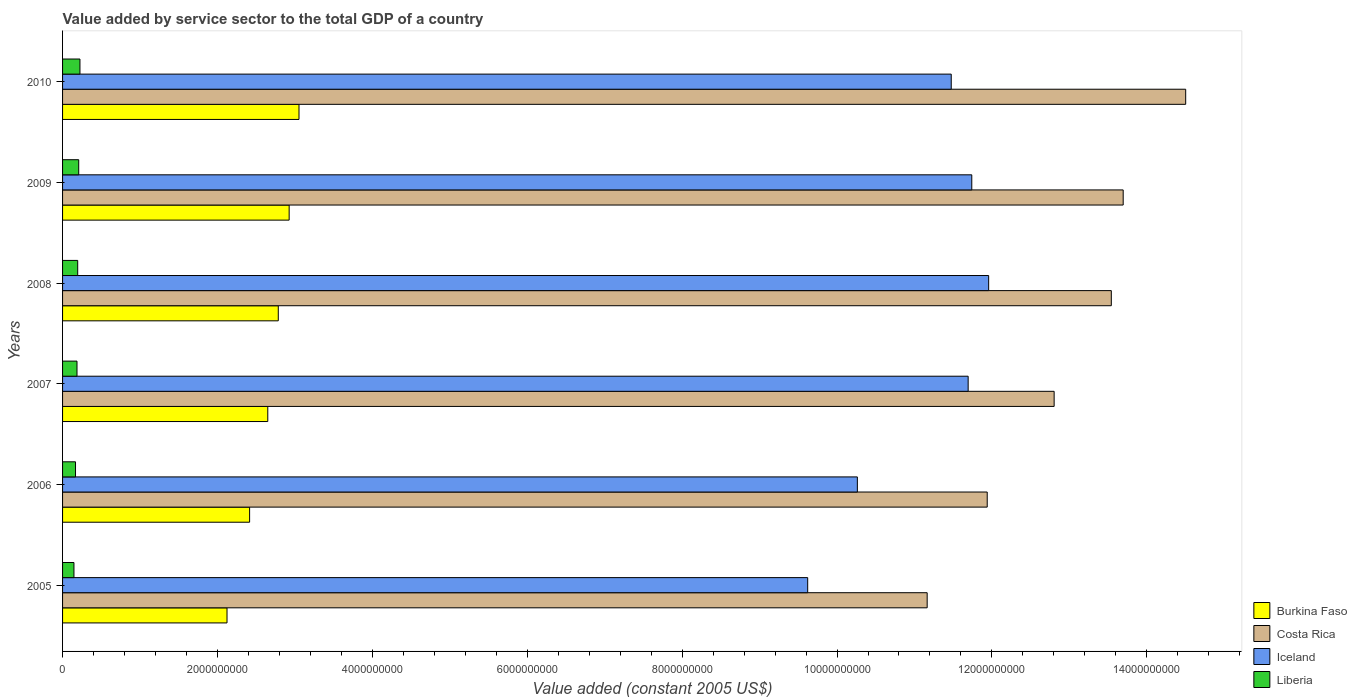How many groups of bars are there?
Provide a succinct answer. 6. Are the number of bars per tick equal to the number of legend labels?
Keep it short and to the point. Yes. How many bars are there on the 6th tick from the bottom?
Ensure brevity in your answer.  4. In how many cases, is the number of bars for a given year not equal to the number of legend labels?
Offer a very short reply. 0. What is the value added by service sector in Iceland in 2010?
Offer a very short reply. 1.15e+1. Across all years, what is the maximum value added by service sector in Burkina Faso?
Provide a short and direct response. 3.05e+09. Across all years, what is the minimum value added by service sector in Iceland?
Your answer should be very brief. 9.62e+09. In which year was the value added by service sector in Burkina Faso maximum?
Keep it short and to the point. 2010. What is the total value added by service sector in Burkina Faso in the graph?
Your answer should be compact. 1.60e+1. What is the difference between the value added by service sector in Liberia in 2005 and that in 2007?
Provide a succinct answer. -3.95e+07. What is the difference between the value added by service sector in Iceland in 2006 and the value added by service sector in Costa Rica in 2008?
Your response must be concise. -3.28e+09. What is the average value added by service sector in Liberia per year?
Give a very brief answer. 1.88e+08. In the year 2006, what is the difference between the value added by service sector in Iceland and value added by service sector in Liberia?
Your response must be concise. 1.01e+1. What is the ratio of the value added by service sector in Iceland in 2009 to that in 2010?
Offer a terse response. 1.02. Is the value added by service sector in Costa Rica in 2009 less than that in 2010?
Your response must be concise. Yes. What is the difference between the highest and the second highest value added by service sector in Burkina Faso?
Your answer should be compact. 1.27e+08. What is the difference between the highest and the lowest value added by service sector in Liberia?
Keep it short and to the point. 7.76e+07. Is it the case that in every year, the sum of the value added by service sector in Liberia and value added by service sector in Costa Rica is greater than the sum of value added by service sector in Iceland and value added by service sector in Burkina Faso?
Your response must be concise. Yes. What does the 4th bar from the top in 2009 represents?
Offer a very short reply. Burkina Faso. What does the 1st bar from the bottom in 2008 represents?
Your response must be concise. Burkina Faso. Are all the bars in the graph horizontal?
Provide a short and direct response. Yes. What is the difference between two consecutive major ticks on the X-axis?
Your response must be concise. 2.00e+09. Are the values on the major ticks of X-axis written in scientific E-notation?
Keep it short and to the point. No. Where does the legend appear in the graph?
Ensure brevity in your answer.  Bottom right. How many legend labels are there?
Offer a very short reply. 4. What is the title of the graph?
Provide a short and direct response. Value added by service sector to the total GDP of a country. What is the label or title of the X-axis?
Make the answer very short. Value added (constant 2005 US$). What is the Value added (constant 2005 US$) in Burkina Faso in 2005?
Provide a succinct answer. 2.12e+09. What is the Value added (constant 2005 US$) in Costa Rica in 2005?
Your answer should be compact. 1.12e+1. What is the Value added (constant 2005 US$) in Iceland in 2005?
Your answer should be compact. 9.62e+09. What is the Value added (constant 2005 US$) in Liberia in 2005?
Your answer should be very brief. 1.47e+08. What is the Value added (constant 2005 US$) of Burkina Faso in 2006?
Provide a short and direct response. 2.42e+09. What is the Value added (constant 2005 US$) in Costa Rica in 2006?
Your response must be concise. 1.19e+1. What is the Value added (constant 2005 US$) of Iceland in 2006?
Provide a short and direct response. 1.03e+1. What is the Value added (constant 2005 US$) of Liberia in 2006?
Make the answer very short. 1.67e+08. What is the Value added (constant 2005 US$) of Burkina Faso in 2007?
Provide a short and direct response. 2.65e+09. What is the Value added (constant 2005 US$) in Costa Rica in 2007?
Your response must be concise. 1.28e+1. What is the Value added (constant 2005 US$) of Iceland in 2007?
Your answer should be compact. 1.17e+1. What is the Value added (constant 2005 US$) in Liberia in 2007?
Provide a short and direct response. 1.86e+08. What is the Value added (constant 2005 US$) of Burkina Faso in 2008?
Give a very brief answer. 2.79e+09. What is the Value added (constant 2005 US$) in Costa Rica in 2008?
Ensure brevity in your answer.  1.35e+1. What is the Value added (constant 2005 US$) of Iceland in 2008?
Your answer should be compact. 1.20e+1. What is the Value added (constant 2005 US$) in Liberia in 2008?
Offer a terse response. 1.95e+08. What is the Value added (constant 2005 US$) in Burkina Faso in 2009?
Provide a succinct answer. 2.93e+09. What is the Value added (constant 2005 US$) in Costa Rica in 2009?
Provide a succinct answer. 1.37e+1. What is the Value added (constant 2005 US$) of Iceland in 2009?
Your response must be concise. 1.17e+1. What is the Value added (constant 2005 US$) of Liberia in 2009?
Give a very brief answer. 2.09e+08. What is the Value added (constant 2005 US$) in Burkina Faso in 2010?
Your answer should be compact. 3.05e+09. What is the Value added (constant 2005 US$) of Costa Rica in 2010?
Provide a succinct answer. 1.45e+1. What is the Value added (constant 2005 US$) in Iceland in 2010?
Keep it short and to the point. 1.15e+1. What is the Value added (constant 2005 US$) in Liberia in 2010?
Offer a very short reply. 2.25e+08. Across all years, what is the maximum Value added (constant 2005 US$) of Burkina Faso?
Ensure brevity in your answer.  3.05e+09. Across all years, what is the maximum Value added (constant 2005 US$) of Costa Rica?
Ensure brevity in your answer.  1.45e+1. Across all years, what is the maximum Value added (constant 2005 US$) in Iceland?
Give a very brief answer. 1.20e+1. Across all years, what is the maximum Value added (constant 2005 US$) of Liberia?
Your answer should be compact. 2.25e+08. Across all years, what is the minimum Value added (constant 2005 US$) of Burkina Faso?
Give a very brief answer. 2.12e+09. Across all years, what is the minimum Value added (constant 2005 US$) of Costa Rica?
Provide a short and direct response. 1.12e+1. Across all years, what is the minimum Value added (constant 2005 US$) of Iceland?
Your answer should be compact. 9.62e+09. Across all years, what is the minimum Value added (constant 2005 US$) in Liberia?
Give a very brief answer. 1.47e+08. What is the total Value added (constant 2005 US$) in Burkina Faso in the graph?
Provide a short and direct response. 1.60e+1. What is the total Value added (constant 2005 US$) of Costa Rica in the graph?
Offer a very short reply. 7.76e+1. What is the total Value added (constant 2005 US$) of Iceland in the graph?
Your answer should be compact. 6.68e+1. What is the total Value added (constant 2005 US$) of Liberia in the graph?
Keep it short and to the point. 1.13e+09. What is the difference between the Value added (constant 2005 US$) of Burkina Faso in 2005 and that in 2006?
Provide a short and direct response. -2.92e+08. What is the difference between the Value added (constant 2005 US$) in Costa Rica in 2005 and that in 2006?
Your answer should be compact. -7.75e+08. What is the difference between the Value added (constant 2005 US$) in Iceland in 2005 and that in 2006?
Give a very brief answer. -6.41e+08. What is the difference between the Value added (constant 2005 US$) of Liberia in 2005 and that in 2006?
Make the answer very short. -2.02e+07. What is the difference between the Value added (constant 2005 US$) in Burkina Faso in 2005 and that in 2007?
Ensure brevity in your answer.  -5.26e+08. What is the difference between the Value added (constant 2005 US$) in Costa Rica in 2005 and that in 2007?
Your response must be concise. -1.64e+09. What is the difference between the Value added (constant 2005 US$) of Iceland in 2005 and that in 2007?
Offer a very short reply. -2.07e+09. What is the difference between the Value added (constant 2005 US$) in Liberia in 2005 and that in 2007?
Keep it short and to the point. -3.95e+07. What is the difference between the Value added (constant 2005 US$) in Burkina Faso in 2005 and that in 2008?
Offer a terse response. -6.62e+08. What is the difference between the Value added (constant 2005 US$) of Costa Rica in 2005 and that in 2008?
Your answer should be compact. -2.38e+09. What is the difference between the Value added (constant 2005 US$) of Iceland in 2005 and that in 2008?
Your response must be concise. -2.34e+09. What is the difference between the Value added (constant 2005 US$) of Liberia in 2005 and that in 2008?
Give a very brief answer. -4.85e+07. What is the difference between the Value added (constant 2005 US$) of Burkina Faso in 2005 and that in 2009?
Your answer should be very brief. -8.02e+08. What is the difference between the Value added (constant 2005 US$) of Costa Rica in 2005 and that in 2009?
Keep it short and to the point. -2.53e+09. What is the difference between the Value added (constant 2005 US$) in Iceland in 2005 and that in 2009?
Keep it short and to the point. -2.12e+09. What is the difference between the Value added (constant 2005 US$) in Liberia in 2005 and that in 2009?
Your answer should be very brief. -6.16e+07. What is the difference between the Value added (constant 2005 US$) in Burkina Faso in 2005 and that in 2010?
Give a very brief answer. -9.29e+08. What is the difference between the Value added (constant 2005 US$) in Costa Rica in 2005 and that in 2010?
Give a very brief answer. -3.34e+09. What is the difference between the Value added (constant 2005 US$) of Iceland in 2005 and that in 2010?
Offer a very short reply. -1.85e+09. What is the difference between the Value added (constant 2005 US$) of Liberia in 2005 and that in 2010?
Offer a very short reply. -7.76e+07. What is the difference between the Value added (constant 2005 US$) of Burkina Faso in 2006 and that in 2007?
Offer a terse response. -2.35e+08. What is the difference between the Value added (constant 2005 US$) in Costa Rica in 2006 and that in 2007?
Offer a very short reply. -8.64e+08. What is the difference between the Value added (constant 2005 US$) in Iceland in 2006 and that in 2007?
Make the answer very short. -1.43e+09. What is the difference between the Value added (constant 2005 US$) of Liberia in 2006 and that in 2007?
Provide a succinct answer. -1.92e+07. What is the difference between the Value added (constant 2005 US$) in Burkina Faso in 2006 and that in 2008?
Provide a succinct answer. -3.70e+08. What is the difference between the Value added (constant 2005 US$) of Costa Rica in 2006 and that in 2008?
Provide a succinct answer. -1.60e+09. What is the difference between the Value added (constant 2005 US$) in Iceland in 2006 and that in 2008?
Give a very brief answer. -1.70e+09. What is the difference between the Value added (constant 2005 US$) in Liberia in 2006 and that in 2008?
Your answer should be compact. -2.83e+07. What is the difference between the Value added (constant 2005 US$) in Burkina Faso in 2006 and that in 2009?
Ensure brevity in your answer.  -5.11e+08. What is the difference between the Value added (constant 2005 US$) of Costa Rica in 2006 and that in 2009?
Your answer should be compact. -1.76e+09. What is the difference between the Value added (constant 2005 US$) in Iceland in 2006 and that in 2009?
Offer a terse response. -1.48e+09. What is the difference between the Value added (constant 2005 US$) of Liberia in 2006 and that in 2009?
Your answer should be compact. -4.13e+07. What is the difference between the Value added (constant 2005 US$) of Burkina Faso in 2006 and that in 2010?
Your answer should be compact. -6.38e+08. What is the difference between the Value added (constant 2005 US$) of Costa Rica in 2006 and that in 2010?
Make the answer very short. -2.56e+09. What is the difference between the Value added (constant 2005 US$) of Iceland in 2006 and that in 2010?
Provide a succinct answer. -1.21e+09. What is the difference between the Value added (constant 2005 US$) in Liberia in 2006 and that in 2010?
Offer a terse response. -5.74e+07. What is the difference between the Value added (constant 2005 US$) of Burkina Faso in 2007 and that in 2008?
Provide a succinct answer. -1.36e+08. What is the difference between the Value added (constant 2005 US$) in Costa Rica in 2007 and that in 2008?
Ensure brevity in your answer.  -7.38e+08. What is the difference between the Value added (constant 2005 US$) of Iceland in 2007 and that in 2008?
Provide a short and direct response. -2.65e+08. What is the difference between the Value added (constant 2005 US$) in Liberia in 2007 and that in 2008?
Give a very brief answer. -9.04e+06. What is the difference between the Value added (constant 2005 US$) in Burkina Faso in 2007 and that in 2009?
Provide a succinct answer. -2.76e+08. What is the difference between the Value added (constant 2005 US$) of Costa Rica in 2007 and that in 2009?
Your answer should be very brief. -8.92e+08. What is the difference between the Value added (constant 2005 US$) of Iceland in 2007 and that in 2009?
Give a very brief answer. -4.66e+07. What is the difference between the Value added (constant 2005 US$) of Liberia in 2007 and that in 2009?
Offer a terse response. -2.21e+07. What is the difference between the Value added (constant 2005 US$) in Burkina Faso in 2007 and that in 2010?
Provide a short and direct response. -4.03e+08. What is the difference between the Value added (constant 2005 US$) in Costa Rica in 2007 and that in 2010?
Provide a short and direct response. -1.70e+09. What is the difference between the Value added (constant 2005 US$) in Iceland in 2007 and that in 2010?
Provide a succinct answer. 2.19e+08. What is the difference between the Value added (constant 2005 US$) of Liberia in 2007 and that in 2010?
Your answer should be compact. -3.81e+07. What is the difference between the Value added (constant 2005 US$) in Burkina Faso in 2008 and that in 2009?
Give a very brief answer. -1.40e+08. What is the difference between the Value added (constant 2005 US$) in Costa Rica in 2008 and that in 2009?
Offer a terse response. -1.53e+08. What is the difference between the Value added (constant 2005 US$) of Iceland in 2008 and that in 2009?
Your response must be concise. 2.18e+08. What is the difference between the Value added (constant 2005 US$) of Liberia in 2008 and that in 2009?
Ensure brevity in your answer.  -1.31e+07. What is the difference between the Value added (constant 2005 US$) of Burkina Faso in 2008 and that in 2010?
Offer a terse response. -2.68e+08. What is the difference between the Value added (constant 2005 US$) of Costa Rica in 2008 and that in 2010?
Give a very brief answer. -9.60e+08. What is the difference between the Value added (constant 2005 US$) of Iceland in 2008 and that in 2010?
Ensure brevity in your answer.  4.83e+08. What is the difference between the Value added (constant 2005 US$) of Liberia in 2008 and that in 2010?
Your answer should be very brief. -2.91e+07. What is the difference between the Value added (constant 2005 US$) in Burkina Faso in 2009 and that in 2010?
Give a very brief answer. -1.27e+08. What is the difference between the Value added (constant 2005 US$) in Costa Rica in 2009 and that in 2010?
Your answer should be very brief. -8.07e+08. What is the difference between the Value added (constant 2005 US$) of Iceland in 2009 and that in 2010?
Give a very brief answer. 2.65e+08. What is the difference between the Value added (constant 2005 US$) in Liberia in 2009 and that in 2010?
Keep it short and to the point. -1.60e+07. What is the difference between the Value added (constant 2005 US$) in Burkina Faso in 2005 and the Value added (constant 2005 US$) in Costa Rica in 2006?
Give a very brief answer. -9.82e+09. What is the difference between the Value added (constant 2005 US$) of Burkina Faso in 2005 and the Value added (constant 2005 US$) of Iceland in 2006?
Ensure brevity in your answer.  -8.14e+09. What is the difference between the Value added (constant 2005 US$) in Burkina Faso in 2005 and the Value added (constant 2005 US$) in Liberia in 2006?
Your answer should be very brief. 1.96e+09. What is the difference between the Value added (constant 2005 US$) of Costa Rica in 2005 and the Value added (constant 2005 US$) of Iceland in 2006?
Your answer should be very brief. 9.01e+08. What is the difference between the Value added (constant 2005 US$) of Costa Rica in 2005 and the Value added (constant 2005 US$) of Liberia in 2006?
Provide a short and direct response. 1.10e+1. What is the difference between the Value added (constant 2005 US$) of Iceland in 2005 and the Value added (constant 2005 US$) of Liberia in 2006?
Offer a very short reply. 9.45e+09. What is the difference between the Value added (constant 2005 US$) in Burkina Faso in 2005 and the Value added (constant 2005 US$) in Costa Rica in 2007?
Your answer should be compact. -1.07e+1. What is the difference between the Value added (constant 2005 US$) in Burkina Faso in 2005 and the Value added (constant 2005 US$) in Iceland in 2007?
Your answer should be compact. -9.57e+09. What is the difference between the Value added (constant 2005 US$) of Burkina Faso in 2005 and the Value added (constant 2005 US$) of Liberia in 2007?
Your response must be concise. 1.94e+09. What is the difference between the Value added (constant 2005 US$) in Costa Rica in 2005 and the Value added (constant 2005 US$) in Iceland in 2007?
Offer a very short reply. -5.29e+08. What is the difference between the Value added (constant 2005 US$) of Costa Rica in 2005 and the Value added (constant 2005 US$) of Liberia in 2007?
Give a very brief answer. 1.10e+1. What is the difference between the Value added (constant 2005 US$) of Iceland in 2005 and the Value added (constant 2005 US$) of Liberia in 2007?
Keep it short and to the point. 9.43e+09. What is the difference between the Value added (constant 2005 US$) of Burkina Faso in 2005 and the Value added (constant 2005 US$) of Costa Rica in 2008?
Provide a short and direct response. -1.14e+1. What is the difference between the Value added (constant 2005 US$) of Burkina Faso in 2005 and the Value added (constant 2005 US$) of Iceland in 2008?
Offer a terse response. -9.83e+09. What is the difference between the Value added (constant 2005 US$) in Burkina Faso in 2005 and the Value added (constant 2005 US$) in Liberia in 2008?
Keep it short and to the point. 1.93e+09. What is the difference between the Value added (constant 2005 US$) of Costa Rica in 2005 and the Value added (constant 2005 US$) of Iceland in 2008?
Offer a very short reply. -7.94e+08. What is the difference between the Value added (constant 2005 US$) of Costa Rica in 2005 and the Value added (constant 2005 US$) of Liberia in 2008?
Provide a succinct answer. 1.10e+1. What is the difference between the Value added (constant 2005 US$) in Iceland in 2005 and the Value added (constant 2005 US$) in Liberia in 2008?
Give a very brief answer. 9.43e+09. What is the difference between the Value added (constant 2005 US$) of Burkina Faso in 2005 and the Value added (constant 2005 US$) of Costa Rica in 2009?
Offer a terse response. -1.16e+1. What is the difference between the Value added (constant 2005 US$) in Burkina Faso in 2005 and the Value added (constant 2005 US$) in Iceland in 2009?
Provide a succinct answer. -9.62e+09. What is the difference between the Value added (constant 2005 US$) in Burkina Faso in 2005 and the Value added (constant 2005 US$) in Liberia in 2009?
Give a very brief answer. 1.91e+09. What is the difference between the Value added (constant 2005 US$) in Costa Rica in 2005 and the Value added (constant 2005 US$) in Iceland in 2009?
Your answer should be compact. -5.76e+08. What is the difference between the Value added (constant 2005 US$) of Costa Rica in 2005 and the Value added (constant 2005 US$) of Liberia in 2009?
Provide a short and direct response. 1.10e+1. What is the difference between the Value added (constant 2005 US$) of Iceland in 2005 and the Value added (constant 2005 US$) of Liberia in 2009?
Ensure brevity in your answer.  9.41e+09. What is the difference between the Value added (constant 2005 US$) in Burkina Faso in 2005 and the Value added (constant 2005 US$) in Costa Rica in 2010?
Make the answer very short. -1.24e+1. What is the difference between the Value added (constant 2005 US$) in Burkina Faso in 2005 and the Value added (constant 2005 US$) in Iceland in 2010?
Provide a succinct answer. -9.35e+09. What is the difference between the Value added (constant 2005 US$) in Burkina Faso in 2005 and the Value added (constant 2005 US$) in Liberia in 2010?
Your response must be concise. 1.90e+09. What is the difference between the Value added (constant 2005 US$) in Costa Rica in 2005 and the Value added (constant 2005 US$) in Iceland in 2010?
Your response must be concise. -3.11e+08. What is the difference between the Value added (constant 2005 US$) of Costa Rica in 2005 and the Value added (constant 2005 US$) of Liberia in 2010?
Your answer should be compact. 1.09e+1. What is the difference between the Value added (constant 2005 US$) of Iceland in 2005 and the Value added (constant 2005 US$) of Liberia in 2010?
Make the answer very short. 9.40e+09. What is the difference between the Value added (constant 2005 US$) in Burkina Faso in 2006 and the Value added (constant 2005 US$) in Costa Rica in 2007?
Your answer should be compact. -1.04e+1. What is the difference between the Value added (constant 2005 US$) of Burkina Faso in 2006 and the Value added (constant 2005 US$) of Iceland in 2007?
Ensure brevity in your answer.  -9.28e+09. What is the difference between the Value added (constant 2005 US$) in Burkina Faso in 2006 and the Value added (constant 2005 US$) in Liberia in 2007?
Give a very brief answer. 2.23e+09. What is the difference between the Value added (constant 2005 US$) in Costa Rica in 2006 and the Value added (constant 2005 US$) in Iceland in 2007?
Make the answer very short. 2.46e+08. What is the difference between the Value added (constant 2005 US$) in Costa Rica in 2006 and the Value added (constant 2005 US$) in Liberia in 2007?
Provide a succinct answer. 1.18e+1. What is the difference between the Value added (constant 2005 US$) of Iceland in 2006 and the Value added (constant 2005 US$) of Liberia in 2007?
Offer a terse response. 1.01e+1. What is the difference between the Value added (constant 2005 US$) in Burkina Faso in 2006 and the Value added (constant 2005 US$) in Costa Rica in 2008?
Your response must be concise. -1.11e+1. What is the difference between the Value added (constant 2005 US$) in Burkina Faso in 2006 and the Value added (constant 2005 US$) in Iceland in 2008?
Ensure brevity in your answer.  -9.54e+09. What is the difference between the Value added (constant 2005 US$) in Burkina Faso in 2006 and the Value added (constant 2005 US$) in Liberia in 2008?
Offer a terse response. 2.22e+09. What is the difference between the Value added (constant 2005 US$) of Costa Rica in 2006 and the Value added (constant 2005 US$) of Iceland in 2008?
Give a very brief answer. -1.86e+07. What is the difference between the Value added (constant 2005 US$) of Costa Rica in 2006 and the Value added (constant 2005 US$) of Liberia in 2008?
Offer a terse response. 1.17e+1. What is the difference between the Value added (constant 2005 US$) in Iceland in 2006 and the Value added (constant 2005 US$) in Liberia in 2008?
Ensure brevity in your answer.  1.01e+1. What is the difference between the Value added (constant 2005 US$) in Burkina Faso in 2006 and the Value added (constant 2005 US$) in Costa Rica in 2009?
Your response must be concise. -1.13e+1. What is the difference between the Value added (constant 2005 US$) of Burkina Faso in 2006 and the Value added (constant 2005 US$) of Iceland in 2009?
Keep it short and to the point. -9.32e+09. What is the difference between the Value added (constant 2005 US$) in Burkina Faso in 2006 and the Value added (constant 2005 US$) in Liberia in 2009?
Ensure brevity in your answer.  2.21e+09. What is the difference between the Value added (constant 2005 US$) of Costa Rica in 2006 and the Value added (constant 2005 US$) of Iceland in 2009?
Your answer should be compact. 1.99e+08. What is the difference between the Value added (constant 2005 US$) of Costa Rica in 2006 and the Value added (constant 2005 US$) of Liberia in 2009?
Make the answer very short. 1.17e+1. What is the difference between the Value added (constant 2005 US$) in Iceland in 2006 and the Value added (constant 2005 US$) in Liberia in 2009?
Give a very brief answer. 1.01e+1. What is the difference between the Value added (constant 2005 US$) of Burkina Faso in 2006 and the Value added (constant 2005 US$) of Costa Rica in 2010?
Make the answer very short. -1.21e+1. What is the difference between the Value added (constant 2005 US$) of Burkina Faso in 2006 and the Value added (constant 2005 US$) of Iceland in 2010?
Make the answer very short. -9.06e+09. What is the difference between the Value added (constant 2005 US$) of Burkina Faso in 2006 and the Value added (constant 2005 US$) of Liberia in 2010?
Offer a very short reply. 2.19e+09. What is the difference between the Value added (constant 2005 US$) of Costa Rica in 2006 and the Value added (constant 2005 US$) of Iceland in 2010?
Your answer should be compact. 4.65e+08. What is the difference between the Value added (constant 2005 US$) of Costa Rica in 2006 and the Value added (constant 2005 US$) of Liberia in 2010?
Provide a succinct answer. 1.17e+1. What is the difference between the Value added (constant 2005 US$) of Iceland in 2006 and the Value added (constant 2005 US$) of Liberia in 2010?
Make the answer very short. 1.00e+1. What is the difference between the Value added (constant 2005 US$) in Burkina Faso in 2007 and the Value added (constant 2005 US$) in Costa Rica in 2008?
Give a very brief answer. -1.09e+1. What is the difference between the Value added (constant 2005 US$) in Burkina Faso in 2007 and the Value added (constant 2005 US$) in Iceland in 2008?
Give a very brief answer. -9.31e+09. What is the difference between the Value added (constant 2005 US$) of Burkina Faso in 2007 and the Value added (constant 2005 US$) of Liberia in 2008?
Make the answer very short. 2.45e+09. What is the difference between the Value added (constant 2005 US$) of Costa Rica in 2007 and the Value added (constant 2005 US$) of Iceland in 2008?
Ensure brevity in your answer.  8.45e+08. What is the difference between the Value added (constant 2005 US$) in Costa Rica in 2007 and the Value added (constant 2005 US$) in Liberia in 2008?
Ensure brevity in your answer.  1.26e+1. What is the difference between the Value added (constant 2005 US$) in Iceland in 2007 and the Value added (constant 2005 US$) in Liberia in 2008?
Keep it short and to the point. 1.15e+1. What is the difference between the Value added (constant 2005 US$) in Burkina Faso in 2007 and the Value added (constant 2005 US$) in Costa Rica in 2009?
Offer a terse response. -1.10e+1. What is the difference between the Value added (constant 2005 US$) of Burkina Faso in 2007 and the Value added (constant 2005 US$) of Iceland in 2009?
Provide a succinct answer. -9.09e+09. What is the difference between the Value added (constant 2005 US$) in Burkina Faso in 2007 and the Value added (constant 2005 US$) in Liberia in 2009?
Give a very brief answer. 2.44e+09. What is the difference between the Value added (constant 2005 US$) in Costa Rica in 2007 and the Value added (constant 2005 US$) in Iceland in 2009?
Provide a succinct answer. 1.06e+09. What is the difference between the Value added (constant 2005 US$) of Costa Rica in 2007 and the Value added (constant 2005 US$) of Liberia in 2009?
Ensure brevity in your answer.  1.26e+1. What is the difference between the Value added (constant 2005 US$) of Iceland in 2007 and the Value added (constant 2005 US$) of Liberia in 2009?
Give a very brief answer. 1.15e+1. What is the difference between the Value added (constant 2005 US$) in Burkina Faso in 2007 and the Value added (constant 2005 US$) in Costa Rica in 2010?
Your answer should be very brief. -1.19e+1. What is the difference between the Value added (constant 2005 US$) in Burkina Faso in 2007 and the Value added (constant 2005 US$) in Iceland in 2010?
Provide a succinct answer. -8.83e+09. What is the difference between the Value added (constant 2005 US$) in Burkina Faso in 2007 and the Value added (constant 2005 US$) in Liberia in 2010?
Make the answer very short. 2.43e+09. What is the difference between the Value added (constant 2005 US$) in Costa Rica in 2007 and the Value added (constant 2005 US$) in Iceland in 2010?
Offer a very short reply. 1.33e+09. What is the difference between the Value added (constant 2005 US$) in Costa Rica in 2007 and the Value added (constant 2005 US$) in Liberia in 2010?
Offer a terse response. 1.26e+1. What is the difference between the Value added (constant 2005 US$) in Iceland in 2007 and the Value added (constant 2005 US$) in Liberia in 2010?
Give a very brief answer. 1.15e+1. What is the difference between the Value added (constant 2005 US$) in Burkina Faso in 2008 and the Value added (constant 2005 US$) in Costa Rica in 2009?
Offer a very short reply. -1.09e+1. What is the difference between the Value added (constant 2005 US$) of Burkina Faso in 2008 and the Value added (constant 2005 US$) of Iceland in 2009?
Ensure brevity in your answer.  -8.95e+09. What is the difference between the Value added (constant 2005 US$) of Burkina Faso in 2008 and the Value added (constant 2005 US$) of Liberia in 2009?
Offer a very short reply. 2.58e+09. What is the difference between the Value added (constant 2005 US$) in Costa Rica in 2008 and the Value added (constant 2005 US$) in Iceland in 2009?
Give a very brief answer. 1.80e+09. What is the difference between the Value added (constant 2005 US$) in Costa Rica in 2008 and the Value added (constant 2005 US$) in Liberia in 2009?
Your answer should be very brief. 1.33e+1. What is the difference between the Value added (constant 2005 US$) in Iceland in 2008 and the Value added (constant 2005 US$) in Liberia in 2009?
Offer a very short reply. 1.17e+1. What is the difference between the Value added (constant 2005 US$) of Burkina Faso in 2008 and the Value added (constant 2005 US$) of Costa Rica in 2010?
Offer a very short reply. -1.17e+1. What is the difference between the Value added (constant 2005 US$) in Burkina Faso in 2008 and the Value added (constant 2005 US$) in Iceland in 2010?
Give a very brief answer. -8.69e+09. What is the difference between the Value added (constant 2005 US$) in Burkina Faso in 2008 and the Value added (constant 2005 US$) in Liberia in 2010?
Make the answer very short. 2.56e+09. What is the difference between the Value added (constant 2005 US$) in Costa Rica in 2008 and the Value added (constant 2005 US$) in Iceland in 2010?
Offer a terse response. 2.07e+09. What is the difference between the Value added (constant 2005 US$) of Costa Rica in 2008 and the Value added (constant 2005 US$) of Liberia in 2010?
Ensure brevity in your answer.  1.33e+1. What is the difference between the Value added (constant 2005 US$) in Iceland in 2008 and the Value added (constant 2005 US$) in Liberia in 2010?
Keep it short and to the point. 1.17e+1. What is the difference between the Value added (constant 2005 US$) of Burkina Faso in 2009 and the Value added (constant 2005 US$) of Costa Rica in 2010?
Provide a succinct answer. -1.16e+1. What is the difference between the Value added (constant 2005 US$) in Burkina Faso in 2009 and the Value added (constant 2005 US$) in Iceland in 2010?
Offer a terse response. -8.55e+09. What is the difference between the Value added (constant 2005 US$) of Burkina Faso in 2009 and the Value added (constant 2005 US$) of Liberia in 2010?
Provide a short and direct response. 2.70e+09. What is the difference between the Value added (constant 2005 US$) in Costa Rica in 2009 and the Value added (constant 2005 US$) in Iceland in 2010?
Offer a terse response. 2.22e+09. What is the difference between the Value added (constant 2005 US$) in Costa Rica in 2009 and the Value added (constant 2005 US$) in Liberia in 2010?
Ensure brevity in your answer.  1.35e+1. What is the difference between the Value added (constant 2005 US$) in Iceland in 2009 and the Value added (constant 2005 US$) in Liberia in 2010?
Keep it short and to the point. 1.15e+1. What is the average Value added (constant 2005 US$) in Burkina Faso per year?
Offer a terse response. 2.66e+09. What is the average Value added (constant 2005 US$) of Costa Rica per year?
Offer a terse response. 1.29e+1. What is the average Value added (constant 2005 US$) in Iceland per year?
Your answer should be very brief. 1.11e+1. What is the average Value added (constant 2005 US$) in Liberia per year?
Offer a very short reply. 1.88e+08. In the year 2005, what is the difference between the Value added (constant 2005 US$) of Burkina Faso and Value added (constant 2005 US$) of Costa Rica?
Offer a very short reply. -9.04e+09. In the year 2005, what is the difference between the Value added (constant 2005 US$) of Burkina Faso and Value added (constant 2005 US$) of Iceland?
Your answer should be compact. -7.50e+09. In the year 2005, what is the difference between the Value added (constant 2005 US$) of Burkina Faso and Value added (constant 2005 US$) of Liberia?
Your answer should be compact. 1.98e+09. In the year 2005, what is the difference between the Value added (constant 2005 US$) of Costa Rica and Value added (constant 2005 US$) of Iceland?
Give a very brief answer. 1.54e+09. In the year 2005, what is the difference between the Value added (constant 2005 US$) in Costa Rica and Value added (constant 2005 US$) in Liberia?
Your answer should be compact. 1.10e+1. In the year 2005, what is the difference between the Value added (constant 2005 US$) in Iceland and Value added (constant 2005 US$) in Liberia?
Your answer should be very brief. 9.47e+09. In the year 2006, what is the difference between the Value added (constant 2005 US$) in Burkina Faso and Value added (constant 2005 US$) in Costa Rica?
Provide a succinct answer. -9.52e+09. In the year 2006, what is the difference between the Value added (constant 2005 US$) of Burkina Faso and Value added (constant 2005 US$) of Iceland?
Give a very brief answer. -7.85e+09. In the year 2006, what is the difference between the Value added (constant 2005 US$) of Burkina Faso and Value added (constant 2005 US$) of Liberia?
Ensure brevity in your answer.  2.25e+09. In the year 2006, what is the difference between the Value added (constant 2005 US$) in Costa Rica and Value added (constant 2005 US$) in Iceland?
Your answer should be compact. 1.68e+09. In the year 2006, what is the difference between the Value added (constant 2005 US$) in Costa Rica and Value added (constant 2005 US$) in Liberia?
Your answer should be compact. 1.18e+1. In the year 2006, what is the difference between the Value added (constant 2005 US$) in Iceland and Value added (constant 2005 US$) in Liberia?
Your response must be concise. 1.01e+1. In the year 2007, what is the difference between the Value added (constant 2005 US$) in Burkina Faso and Value added (constant 2005 US$) in Costa Rica?
Offer a very short reply. -1.02e+1. In the year 2007, what is the difference between the Value added (constant 2005 US$) of Burkina Faso and Value added (constant 2005 US$) of Iceland?
Offer a terse response. -9.04e+09. In the year 2007, what is the difference between the Value added (constant 2005 US$) in Burkina Faso and Value added (constant 2005 US$) in Liberia?
Your response must be concise. 2.46e+09. In the year 2007, what is the difference between the Value added (constant 2005 US$) of Costa Rica and Value added (constant 2005 US$) of Iceland?
Ensure brevity in your answer.  1.11e+09. In the year 2007, what is the difference between the Value added (constant 2005 US$) of Costa Rica and Value added (constant 2005 US$) of Liberia?
Your response must be concise. 1.26e+1. In the year 2007, what is the difference between the Value added (constant 2005 US$) of Iceland and Value added (constant 2005 US$) of Liberia?
Offer a terse response. 1.15e+1. In the year 2008, what is the difference between the Value added (constant 2005 US$) in Burkina Faso and Value added (constant 2005 US$) in Costa Rica?
Give a very brief answer. -1.08e+1. In the year 2008, what is the difference between the Value added (constant 2005 US$) of Burkina Faso and Value added (constant 2005 US$) of Iceland?
Offer a very short reply. -9.17e+09. In the year 2008, what is the difference between the Value added (constant 2005 US$) in Burkina Faso and Value added (constant 2005 US$) in Liberia?
Your response must be concise. 2.59e+09. In the year 2008, what is the difference between the Value added (constant 2005 US$) in Costa Rica and Value added (constant 2005 US$) in Iceland?
Offer a very short reply. 1.58e+09. In the year 2008, what is the difference between the Value added (constant 2005 US$) of Costa Rica and Value added (constant 2005 US$) of Liberia?
Keep it short and to the point. 1.33e+1. In the year 2008, what is the difference between the Value added (constant 2005 US$) of Iceland and Value added (constant 2005 US$) of Liberia?
Offer a very short reply. 1.18e+1. In the year 2009, what is the difference between the Value added (constant 2005 US$) in Burkina Faso and Value added (constant 2005 US$) in Costa Rica?
Provide a short and direct response. -1.08e+1. In the year 2009, what is the difference between the Value added (constant 2005 US$) in Burkina Faso and Value added (constant 2005 US$) in Iceland?
Offer a very short reply. -8.81e+09. In the year 2009, what is the difference between the Value added (constant 2005 US$) in Burkina Faso and Value added (constant 2005 US$) in Liberia?
Your answer should be very brief. 2.72e+09. In the year 2009, what is the difference between the Value added (constant 2005 US$) in Costa Rica and Value added (constant 2005 US$) in Iceland?
Ensure brevity in your answer.  1.96e+09. In the year 2009, what is the difference between the Value added (constant 2005 US$) in Costa Rica and Value added (constant 2005 US$) in Liberia?
Provide a short and direct response. 1.35e+1. In the year 2009, what is the difference between the Value added (constant 2005 US$) of Iceland and Value added (constant 2005 US$) of Liberia?
Make the answer very short. 1.15e+1. In the year 2010, what is the difference between the Value added (constant 2005 US$) of Burkina Faso and Value added (constant 2005 US$) of Costa Rica?
Ensure brevity in your answer.  -1.14e+1. In the year 2010, what is the difference between the Value added (constant 2005 US$) of Burkina Faso and Value added (constant 2005 US$) of Iceland?
Your response must be concise. -8.42e+09. In the year 2010, what is the difference between the Value added (constant 2005 US$) of Burkina Faso and Value added (constant 2005 US$) of Liberia?
Your answer should be compact. 2.83e+09. In the year 2010, what is the difference between the Value added (constant 2005 US$) in Costa Rica and Value added (constant 2005 US$) in Iceland?
Provide a short and direct response. 3.03e+09. In the year 2010, what is the difference between the Value added (constant 2005 US$) in Costa Rica and Value added (constant 2005 US$) in Liberia?
Offer a terse response. 1.43e+1. In the year 2010, what is the difference between the Value added (constant 2005 US$) of Iceland and Value added (constant 2005 US$) of Liberia?
Ensure brevity in your answer.  1.13e+1. What is the ratio of the Value added (constant 2005 US$) of Burkina Faso in 2005 to that in 2006?
Ensure brevity in your answer.  0.88. What is the ratio of the Value added (constant 2005 US$) of Costa Rica in 2005 to that in 2006?
Make the answer very short. 0.94. What is the ratio of the Value added (constant 2005 US$) in Iceland in 2005 to that in 2006?
Give a very brief answer. 0.94. What is the ratio of the Value added (constant 2005 US$) of Liberia in 2005 to that in 2006?
Offer a terse response. 0.88. What is the ratio of the Value added (constant 2005 US$) of Burkina Faso in 2005 to that in 2007?
Keep it short and to the point. 0.8. What is the ratio of the Value added (constant 2005 US$) in Costa Rica in 2005 to that in 2007?
Your answer should be very brief. 0.87. What is the ratio of the Value added (constant 2005 US$) of Iceland in 2005 to that in 2007?
Give a very brief answer. 0.82. What is the ratio of the Value added (constant 2005 US$) in Liberia in 2005 to that in 2007?
Your answer should be very brief. 0.79. What is the ratio of the Value added (constant 2005 US$) in Burkina Faso in 2005 to that in 2008?
Give a very brief answer. 0.76. What is the ratio of the Value added (constant 2005 US$) in Costa Rica in 2005 to that in 2008?
Give a very brief answer. 0.82. What is the ratio of the Value added (constant 2005 US$) in Iceland in 2005 to that in 2008?
Your answer should be very brief. 0.8. What is the ratio of the Value added (constant 2005 US$) in Liberia in 2005 to that in 2008?
Give a very brief answer. 0.75. What is the ratio of the Value added (constant 2005 US$) of Burkina Faso in 2005 to that in 2009?
Make the answer very short. 0.73. What is the ratio of the Value added (constant 2005 US$) of Costa Rica in 2005 to that in 2009?
Your answer should be very brief. 0.82. What is the ratio of the Value added (constant 2005 US$) of Iceland in 2005 to that in 2009?
Your answer should be very brief. 0.82. What is the ratio of the Value added (constant 2005 US$) of Liberia in 2005 to that in 2009?
Your answer should be compact. 0.7. What is the ratio of the Value added (constant 2005 US$) in Burkina Faso in 2005 to that in 2010?
Offer a very short reply. 0.7. What is the ratio of the Value added (constant 2005 US$) of Costa Rica in 2005 to that in 2010?
Your response must be concise. 0.77. What is the ratio of the Value added (constant 2005 US$) of Iceland in 2005 to that in 2010?
Keep it short and to the point. 0.84. What is the ratio of the Value added (constant 2005 US$) of Liberia in 2005 to that in 2010?
Give a very brief answer. 0.65. What is the ratio of the Value added (constant 2005 US$) in Burkina Faso in 2006 to that in 2007?
Your answer should be compact. 0.91. What is the ratio of the Value added (constant 2005 US$) of Costa Rica in 2006 to that in 2007?
Make the answer very short. 0.93. What is the ratio of the Value added (constant 2005 US$) in Iceland in 2006 to that in 2007?
Offer a very short reply. 0.88. What is the ratio of the Value added (constant 2005 US$) in Liberia in 2006 to that in 2007?
Your answer should be very brief. 0.9. What is the ratio of the Value added (constant 2005 US$) in Burkina Faso in 2006 to that in 2008?
Your answer should be compact. 0.87. What is the ratio of the Value added (constant 2005 US$) in Costa Rica in 2006 to that in 2008?
Offer a very short reply. 0.88. What is the ratio of the Value added (constant 2005 US$) in Iceland in 2006 to that in 2008?
Give a very brief answer. 0.86. What is the ratio of the Value added (constant 2005 US$) in Liberia in 2006 to that in 2008?
Ensure brevity in your answer.  0.86. What is the ratio of the Value added (constant 2005 US$) of Burkina Faso in 2006 to that in 2009?
Keep it short and to the point. 0.83. What is the ratio of the Value added (constant 2005 US$) of Costa Rica in 2006 to that in 2009?
Your response must be concise. 0.87. What is the ratio of the Value added (constant 2005 US$) in Iceland in 2006 to that in 2009?
Offer a very short reply. 0.87. What is the ratio of the Value added (constant 2005 US$) of Liberia in 2006 to that in 2009?
Provide a short and direct response. 0.8. What is the ratio of the Value added (constant 2005 US$) in Burkina Faso in 2006 to that in 2010?
Provide a succinct answer. 0.79. What is the ratio of the Value added (constant 2005 US$) of Costa Rica in 2006 to that in 2010?
Offer a terse response. 0.82. What is the ratio of the Value added (constant 2005 US$) of Iceland in 2006 to that in 2010?
Give a very brief answer. 0.89. What is the ratio of the Value added (constant 2005 US$) of Liberia in 2006 to that in 2010?
Your answer should be compact. 0.74. What is the ratio of the Value added (constant 2005 US$) in Burkina Faso in 2007 to that in 2008?
Ensure brevity in your answer.  0.95. What is the ratio of the Value added (constant 2005 US$) in Costa Rica in 2007 to that in 2008?
Offer a terse response. 0.95. What is the ratio of the Value added (constant 2005 US$) in Iceland in 2007 to that in 2008?
Keep it short and to the point. 0.98. What is the ratio of the Value added (constant 2005 US$) of Liberia in 2007 to that in 2008?
Make the answer very short. 0.95. What is the ratio of the Value added (constant 2005 US$) of Burkina Faso in 2007 to that in 2009?
Your response must be concise. 0.91. What is the ratio of the Value added (constant 2005 US$) of Costa Rica in 2007 to that in 2009?
Offer a terse response. 0.93. What is the ratio of the Value added (constant 2005 US$) of Iceland in 2007 to that in 2009?
Provide a short and direct response. 1. What is the ratio of the Value added (constant 2005 US$) of Liberia in 2007 to that in 2009?
Make the answer very short. 0.89. What is the ratio of the Value added (constant 2005 US$) in Burkina Faso in 2007 to that in 2010?
Provide a short and direct response. 0.87. What is the ratio of the Value added (constant 2005 US$) in Costa Rica in 2007 to that in 2010?
Your response must be concise. 0.88. What is the ratio of the Value added (constant 2005 US$) in Liberia in 2007 to that in 2010?
Your response must be concise. 0.83. What is the ratio of the Value added (constant 2005 US$) in Burkina Faso in 2008 to that in 2009?
Keep it short and to the point. 0.95. What is the ratio of the Value added (constant 2005 US$) of Iceland in 2008 to that in 2009?
Make the answer very short. 1.02. What is the ratio of the Value added (constant 2005 US$) of Liberia in 2008 to that in 2009?
Ensure brevity in your answer.  0.94. What is the ratio of the Value added (constant 2005 US$) of Burkina Faso in 2008 to that in 2010?
Provide a succinct answer. 0.91. What is the ratio of the Value added (constant 2005 US$) in Costa Rica in 2008 to that in 2010?
Ensure brevity in your answer.  0.93. What is the ratio of the Value added (constant 2005 US$) in Iceland in 2008 to that in 2010?
Your answer should be very brief. 1.04. What is the ratio of the Value added (constant 2005 US$) of Liberia in 2008 to that in 2010?
Provide a succinct answer. 0.87. What is the ratio of the Value added (constant 2005 US$) in Burkina Faso in 2009 to that in 2010?
Provide a short and direct response. 0.96. What is the ratio of the Value added (constant 2005 US$) of Iceland in 2009 to that in 2010?
Your answer should be very brief. 1.02. What is the ratio of the Value added (constant 2005 US$) in Liberia in 2009 to that in 2010?
Keep it short and to the point. 0.93. What is the difference between the highest and the second highest Value added (constant 2005 US$) of Burkina Faso?
Keep it short and to the point. 1.27e+08. What is the difference between the highest and the second highest Value added (constant 2005 US$) of Costa Rica?
Your answer should be very brief. 8.07e+08. What is the difference between the highest and the second highest Value added (constant 2005 US$) in Iceland?
Offer a very short reply. 2.18e+08. What is the difference between the highest and the second highest Value added (constant 2005 US$) in Liberia?
Your answer should be compact. 1.60e+07. What is the difference between the highest and the lowest Value added (constant 2005 US$) of Burkina Faso?
Offer a terse response. 9.29e+08. What is the difference between the highest and the lowest Value added (constant 2005 US$) of Costa Rica?
Offer a very short reply. 3.34e+09. What is the difference between the highest and the lowest Value added (constant 2005 US$) of Iceland?
Your response must be concise. 2.34e+09. What is the difference between the highest and the lowest Value added (constant 2005 US$) of Liberia?
Keep it short and to the point. 7.76e+07. 